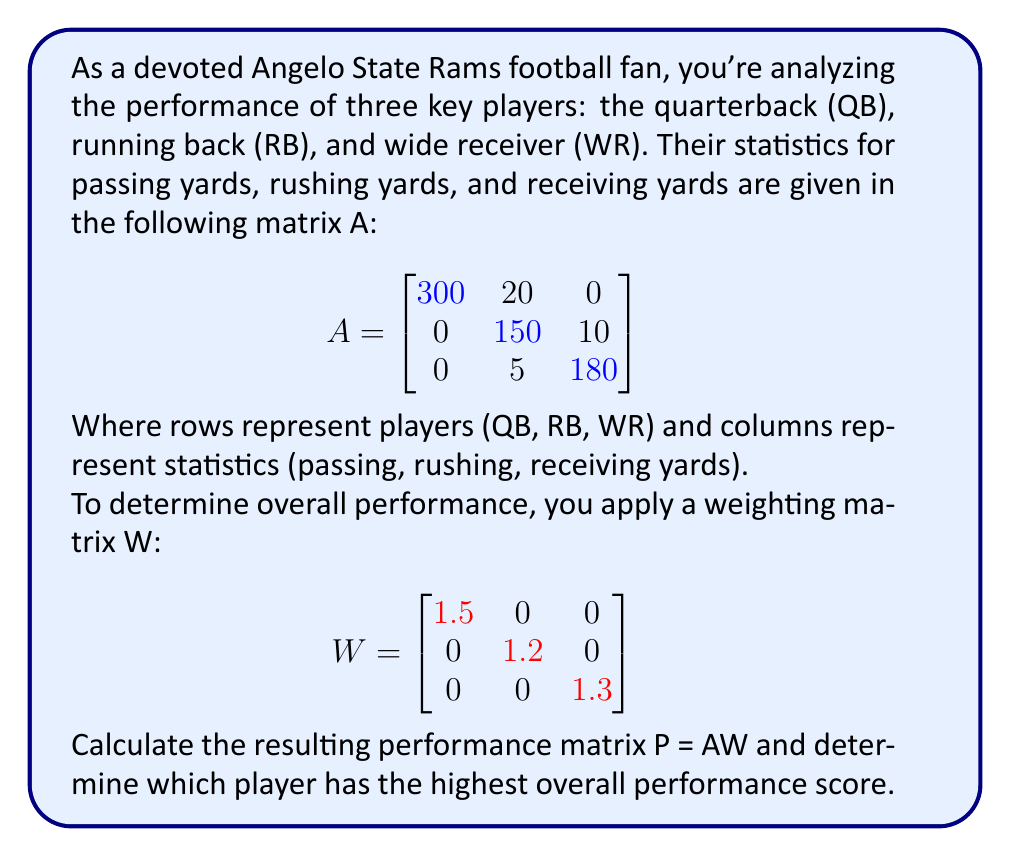Provide a solution to this math problem. Let's approach this step-by-step:

1) First, we need to multiply matrix A by matrix W. The resulting matrix P will have the same dimensions as A (3x3).

2) To multiply these matrices, we use the formula:
   $$(AW)_{ij} = \sum_{k=1}^{3} A_{ik} \cdot W_{kj}$$

3) Let's calculate each element of P:

   $P_{11} = 300 \cdot 1.5 + 20 \cdot 0 + 0 \cdot 0 = 450$
   $P_{12} = 300 \cdot 0 + 20 \cdot 1.2 + 0 \cdot 0 = 24$
   $P_{13} = 300 \cdot 0 + 20 \cdot 0 + 0 \cdot 1.3 = 0$

   $P_{21} = 0 \cdot 1.5 + 150 \cdot 0 + 10 \cdot 0 = 0$
   $P_{22} = 0 \cdot 0 + 150 \cdot 1.2 + 10 \cdot 0 = 180$
   $P_{23} = 0 \cdot 0 + 150 \cdot 0 + 10 \cdot 1.3 = 13$

   $P_{31} = 0 \cdot 1.5 + 5 \cdot 0 + 180 \cdot 0 = 0$
   $P_{32} = 0 \cdot 0 + 5 \cdot 1.2 + 180 \cdot 0 = 6$
   $P_{33} = 0 \cdot 0 + 5 \cdot 0 + 180 \cdot 1.3 = 234$

4) The resulting performance matrix P is:

   $$P = \begin{bmatrix}
   450 & 24 & 0 \\
   0 & 180 & 13 \\
   0 & 6 & 234
   \end{bmatrix}$$

5) To determine the overall performance score for each player, we sum across each row:

   QB: 450 + 24 + 0 = 474
   RB: 0 + 180 + 13 = 193
   WR: 0 + 6 + 234 = 240

6) The highest score is 474, corresponding to the quarterback (QB).
Answer: Quarterback (QB) with score 474 